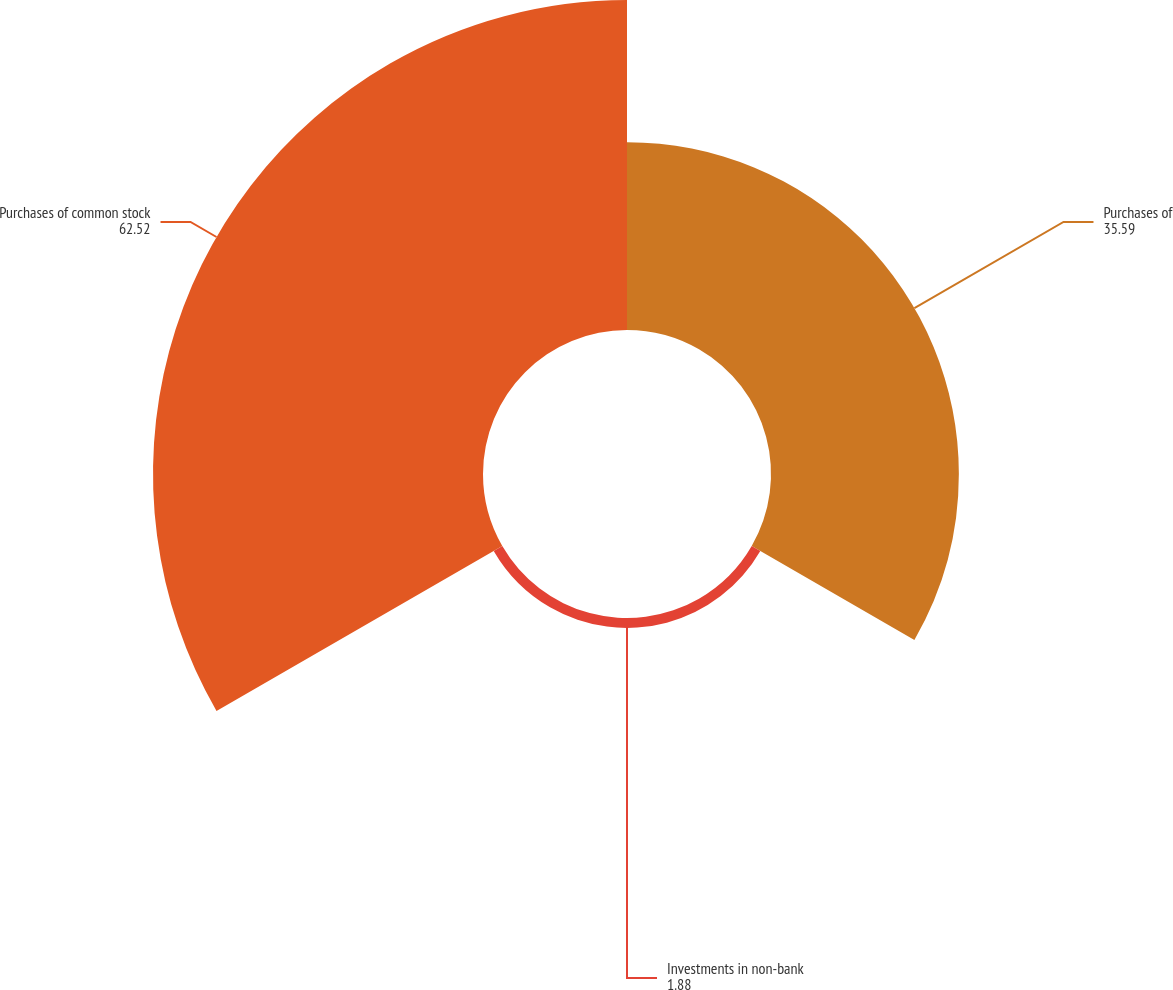<chart> <loc_0><loc_0><loc_500><loc_500><pie_chart><fcel>Purchases of<fcel>Investments in non-bank<fcel>Purchases of common stock<nl><fcel>35.59%<fcel>1.88%<fcel>62.52%<nl></chart> 